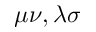Convert formula to latex. <formula><loc_0><loc_0><loc_500><loc_500>\mu \nu , \lambda \sigma</formula> 